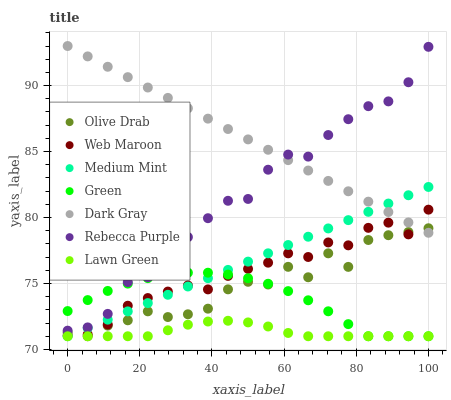Does Lawn Green have the minimum area under the curve?
Answer yes or no. Yes. Does Dark Gray have the maximum area under the curve?
Answer yes or no. Yes. Does Web Maroon have the minimum area under the curve?
Answer yes or no. No. Does Web Maroon have the maximum area under the curve?
Answer yes or no. No. Is Medium Mint the smoothest?
Answer yes or no. Yes. Is Olive Drab the roughest?
Answer yes or no. Yes. Is Lawn Green the smoothest?
Answer yes or no. No. Is Lawn Green the roughest?
Answer yes or no. No. Does Medium Mint have the lowest value?
Answer yes or no. Yes. Does Web Maroon have the lowest value?
Answer yes or no. No. Does Dark Gray have the highest value?
Answer yes or no. Yes. Does Web Maroon have the highest value?
Answer yes or no. No. Is Lawn Green less than Web Maroon?
Answer yes or no. Yes. Is Rebecca Purple greater than Web Maroon?
Answer yes or no. Yes. Does Medium Mint intersect Olive Drab?
Answer yes or no. Yes. Is Medium Mint less than Olive Drab?
Answer yes or no. No. Is Medium Mint greater than Olive Drab?
Answer yes or no. No. Does Lawn Green intersect Web Maroon?
Answer yes or no. No. 